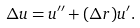Convert formula to latex. <formula><loc_0><loc_0><loc_500><loc_500>\Delta u = u ^ { \prime \prime } + ( \Delta r ) u ^ { \prime } .</formula> 